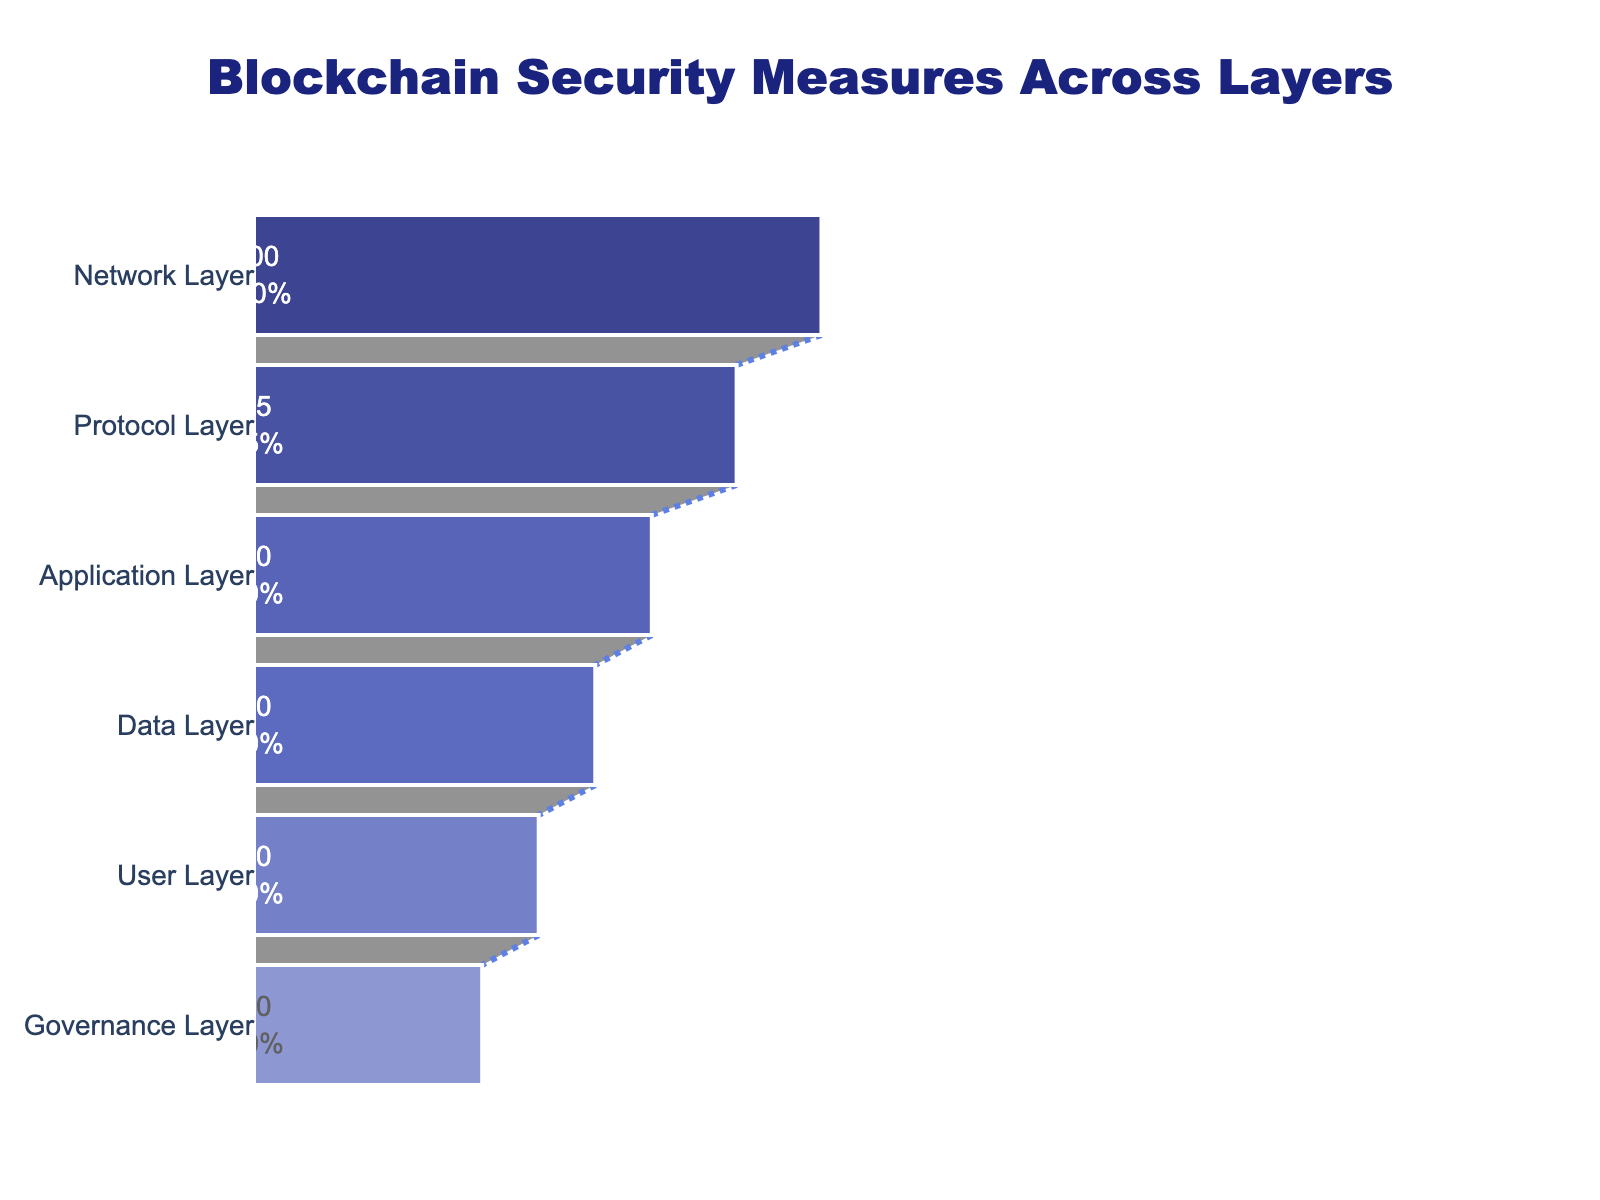What is the title of the funnel chart? The title is typically located at the top center of the chart. It provides a quick overview of what the chart represents. In this case, the title reads "Blockchain Security Measures Across Layers."
Answer: Blockchain Security Measures Across Layers Which layer has the highest percentage of applied security measures? The funnel chart's top segment represents the Network Layer, labeled "Firewalls and IDS/IPS," with a percentage of 100. It is visually the largest section, indicating the highest measure.
Answer: Network Layer What security measure is associated with the Protocol Layer and its percentage? Following the stages labeled on the left and their associated measures, the Protocol Layer is the second stage with a security measure of "Consensus Mechanisms" and a percentage of 85.
Answer: Consensus Mechanisms, 85% How many layers are depicted in the funnel chart? By counting the distinct segments from top to bottom vertically, there are six labeled stages: Network, Protocol, Application, Data, User, and Governance Layers.
Answer: 6 What is the percentage decrease from the Network Layer to the Protocol Layer? The Network Layer has 100%, and the Protocol Layer has 85%. Subtracting to find the difference, 100% - 85% equals a 15% decrease.
Answer: 15% Which layer has the lowest percentage of applied security measures? The smallest segment of the funnel, indicating the lowest point, is the Governance Layer, labeled with a percentage of 40.
Answer: Governance Layer What are the security measures for the User and Governance Layers respectively, and their percentages? By referring to the labels associated with the User Layer and Governance Layer, the User Layer has "Multi-Factor Authentication" at 50%, and the Governance Layer has "Access Control Lists" at 40%.
Answer: Multi-Factor Authentication, 50%; Access Control Lists, 40% Is the percentage of applied security measures higher in the Data Layer or the User Layer? Comparing the labels, the Data Layer has a percentage of 60%, while the User Layer is at 50%. Therefore, the Data Layer has a higher percentage.
Answer: Data Layer What is the average percentage of applied security measures across all layers? Summing up all percentages (100 + 85 + 70 + 60 + 50 + 40 = 405) and dividing by the number of layers (6) results in 405/6 = 67.5. The average percentage is 67.5%.
Answer: 67.5% What percentage of the applied security measures in the Protocol Layer is left when compared to the Application Layer? Subtract the Protocol Layer percentage (85%) from the Application Layer percentage (70%) (85% - 70% = 15%).
Answer: 15% 